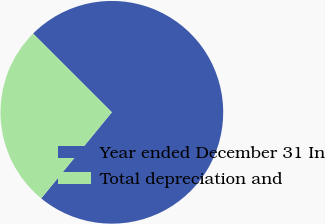Convert chart. <chart><loc_0><loc_0><loc_500><loc_500><pie_chart><fcel>Year ended December 31 In<fcel>Total depreciation and<nl><fcel>73.44%<fcel>26.56%<nl></chart> 